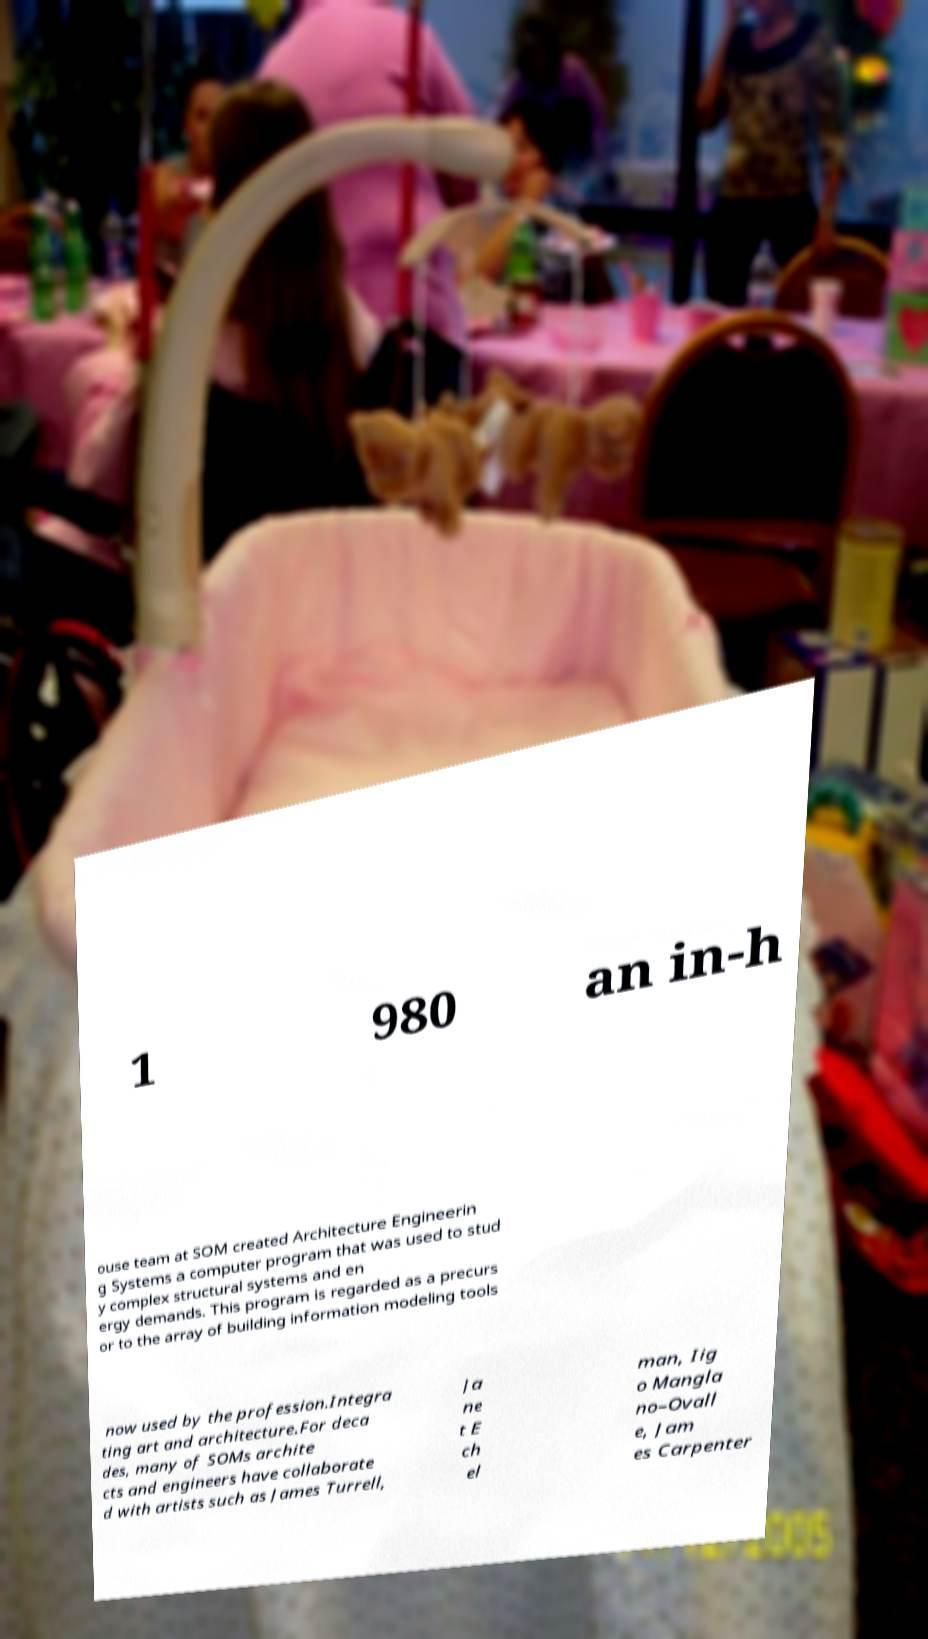Can you read and provide the text displayed in the image?This photo seems to have some interesting text. Can you extract and type it out for me? 1 980 an in-h ouse team at SOM created Architecture Engineerin g Systems a computer program that was used to stud y complex structural systems and en ergy demands. This program is regarded as a precurs or to the array of building information modeling tools now used by the profession.Integra ting art and architecture.For deca des, many of SOMs archite cts and engineers have collaborate d with artists such as James Turrell, Ja ne t E ch el man, Iig o Mangla no–Ovall e, Jam es Carpenter 